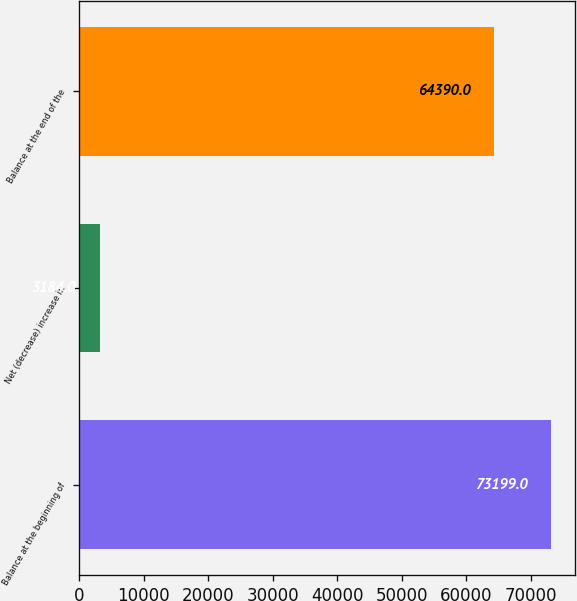<chart> <loc_0><loc_0><loc_500><loc_500><bar_chart><fcel>Balance at the beginning of<fcel>Net (decrease) increase in<fcel>Balance at the end of the<nl><fcel>73199<fcel>3184<fcel>64390<nl></chart> 